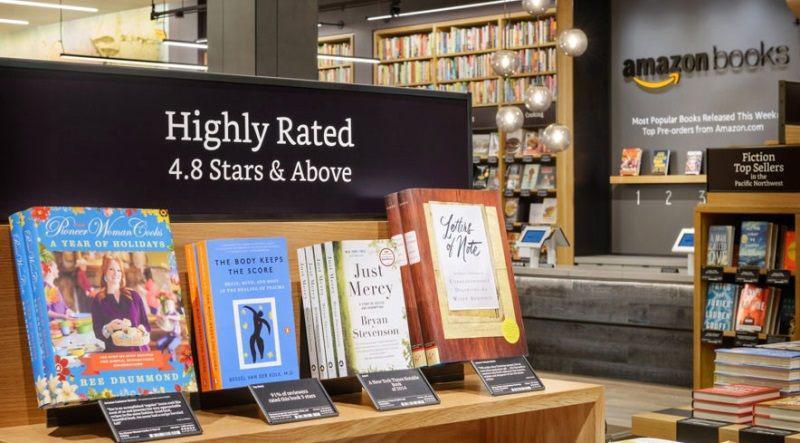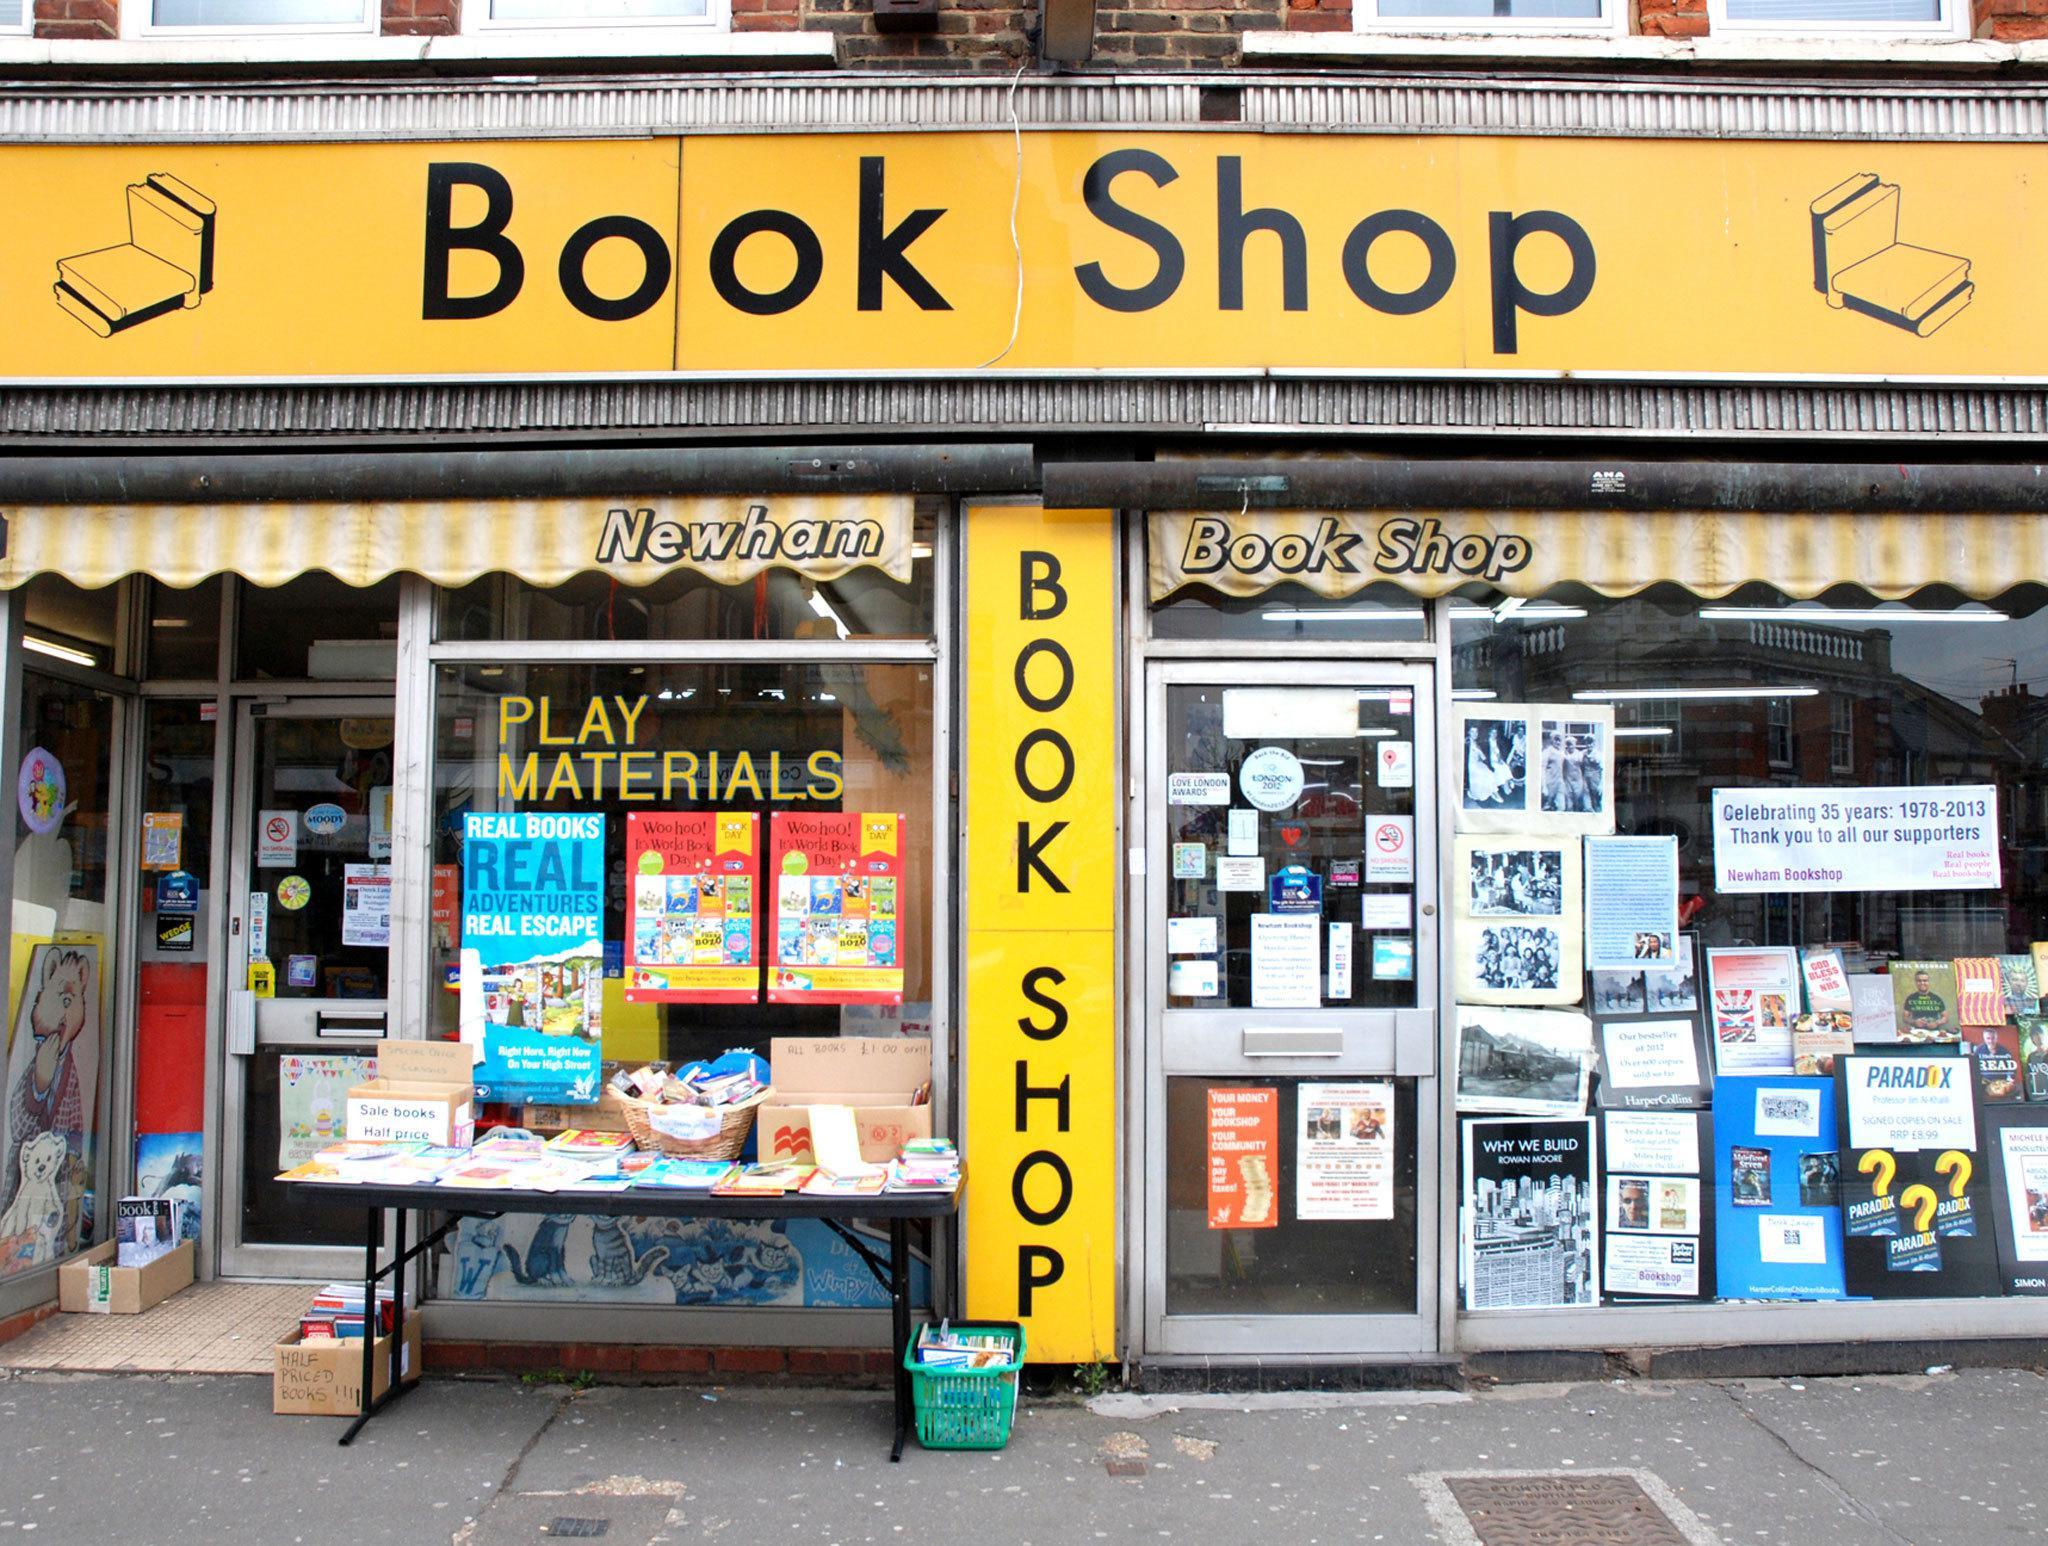The first image is the image on the left, the second image is the image on the right. For the images displayed, is the sentence "One of the images displays an outdoor sign, with vertical letters depicting a book store." factually correct? Answer yes or no. Yes. The first image is the image on the left, the second image is the image on the right. Examine the images to the left and right. Is the description "An image shows the exterior of a bookstore with yellow-background signs above the entrance and running vertically beside a door." accurate? Answer yes or no. Yes. The first image is the image on the left, the second image is the image on the right. For the images shown, is this caption "The right image shows the exterior of a bookshop." true? Answer yes or no. Yes. The first image is the image on the left, the second image is the image on the right. For the images displayed, is the sentence "One image is the interior of a bookshop and one image is the exterior of a bookshop." factually correct? Answer yes or no. Yes. 